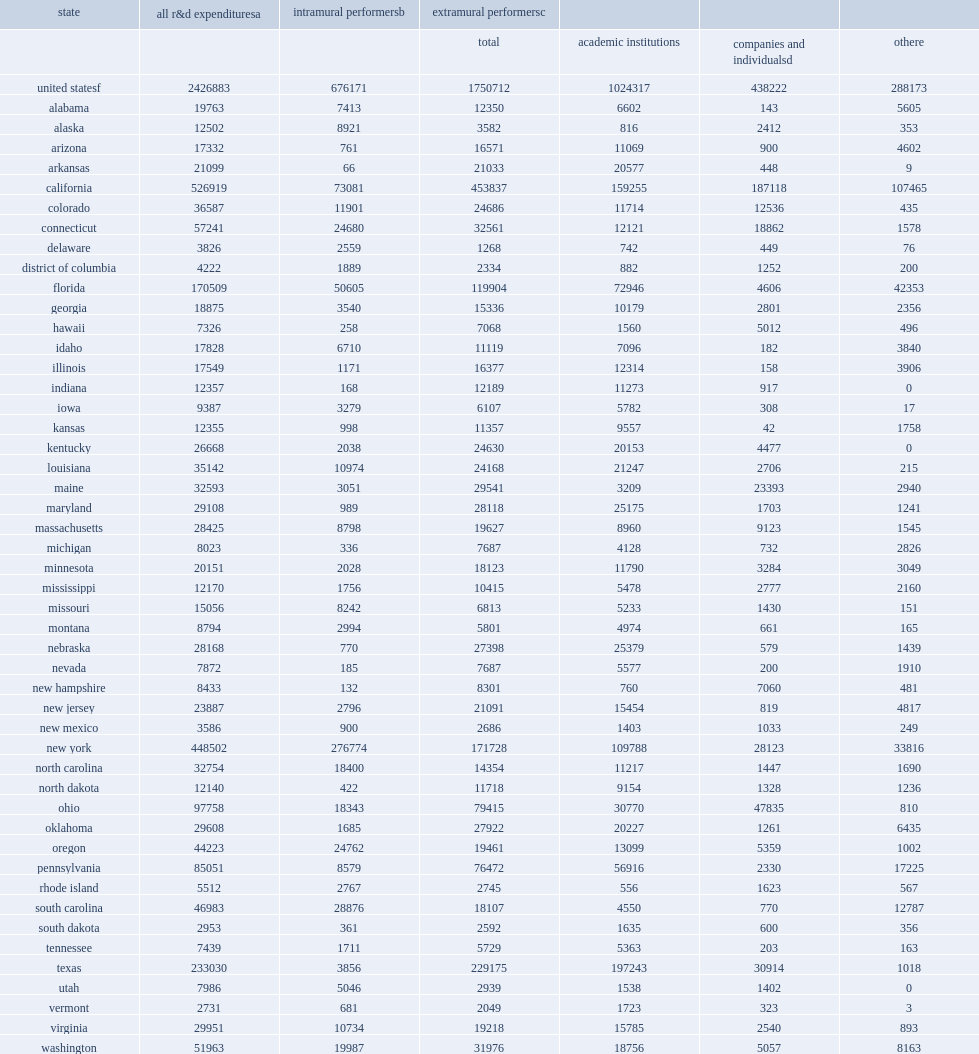How many thousand dollars of new york's r&d expenditures are directed toward intramural performance? 276774.0. How many thousand dollars of california's r&d is directed toward extramural performers? 453837.0. How many thousand dollars in expenditures for intramural r&d performed by all state agencies in fy 2019? 676171.0. How many percent did six states account for of the $676 million in expenditures for intramural r&d performed by all state agencies in fy 2019: new york ($277 million), california ($73 million), florida ($51 million), south carolina ($29 million), oregon ($25 million), and connecticut ($25 million)? 0.708072. How many thousand dollars in fy 2019 state government expenditures for extramural r&d performance? 1750712.0. How many percent did six states account for of the total $1.8 billion in fy 2019 state government expenditures for extramural r&d performance: california ($454 million), texas ($229 million), new york ($172 million), florida ($120 million), ohio ($79 million), and pennsylvania ($76 million)? 0.645755. 